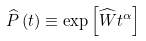<formula> <loc_0><loc_0><loc_500><loc_500>\widehat { P } \left ( t \right ) \equiv \exp \left [ \widehat { W } t ^ { \alpha } \right ]</formula> 